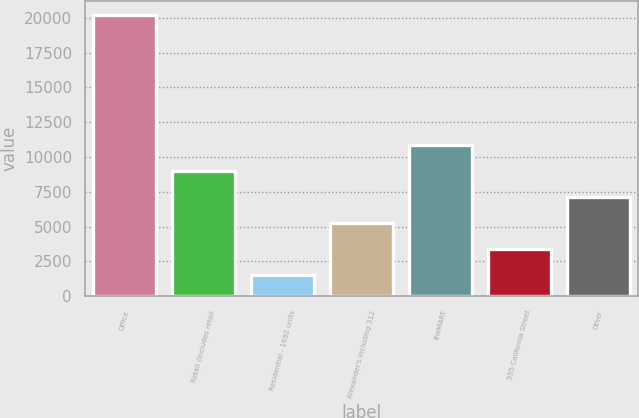Convert chart. <chart><loc_0><loc_0><loc_500><loc_500><bar_chart><fcel>Office<fcel>Retail (includes retail<fcel>Residential - 1692 units<fcel>Alexander's including 312<fcel>theMART<fcel>555 California Street<fcel>Other<nl><fcel>20227<fcel>9026.2<fcel>1559<fcel>5292.6<fcel>10893<fcel>3425.8<fcel>7159.4<nl></chart> 